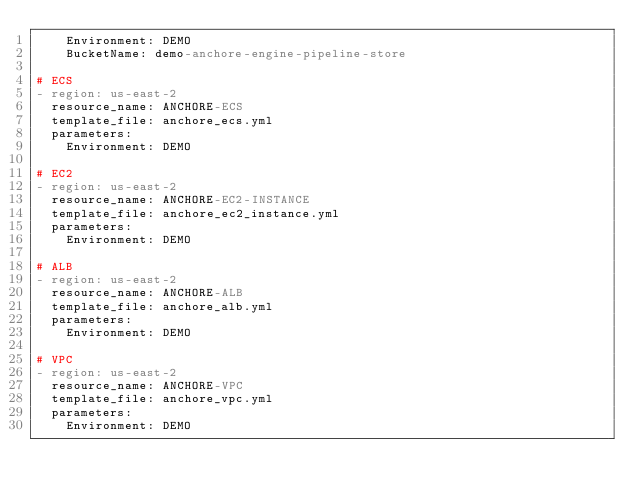Convert code to text. <code><loc_0><loc_0><loc_500><loc_500><_YAML_>    Environment: DEMO
    BucketName: demo-anchore-engine-pipeline-store

# ECS
- region: us-east-2
  resource_name: ANCHORE-ECS
  template_file: anchore_ecs.yml
  parameters:
    Environment: DEMO

# EC2
- region: us-east-2
  resource_name: ANCHORE-EC2-INSTANCE
  template_file: anchore_ec2_instance.yml
  parameters:
    Environment: DEMO

# ALB
- region: us-east-2
  resource_name: ANCHORE-ALB
  template_file: anchore_alb.yml
  parameters:
    Environment: DEMO

# VPC
- region: us-east-2
  resource_name: ANCHORE-VPC
  template_file: anchore_vpc.yml
  parameters:
    Environment: DEMO
    </code> 